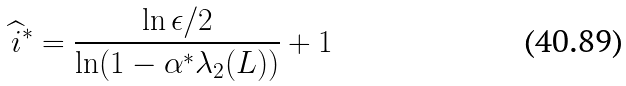Convert formula to latex. <formula><loc_0><loc_0><loc_500><loc_500>\widehat { i } ^ { \ast } = \frac { \ln \epsilon / 2 } { \ln ( 1 - \alpha ^ { \ast } \lambda _ { 2 } ( L ) ) } + 1</formula> 